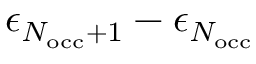Convert formula to latex. <formula><loc_0><loc_0><loc_500><loc_500>\epsilon _ { N _ { o c c } + 1 } - \epsilon _ { N _ { o c c } }</formula> 